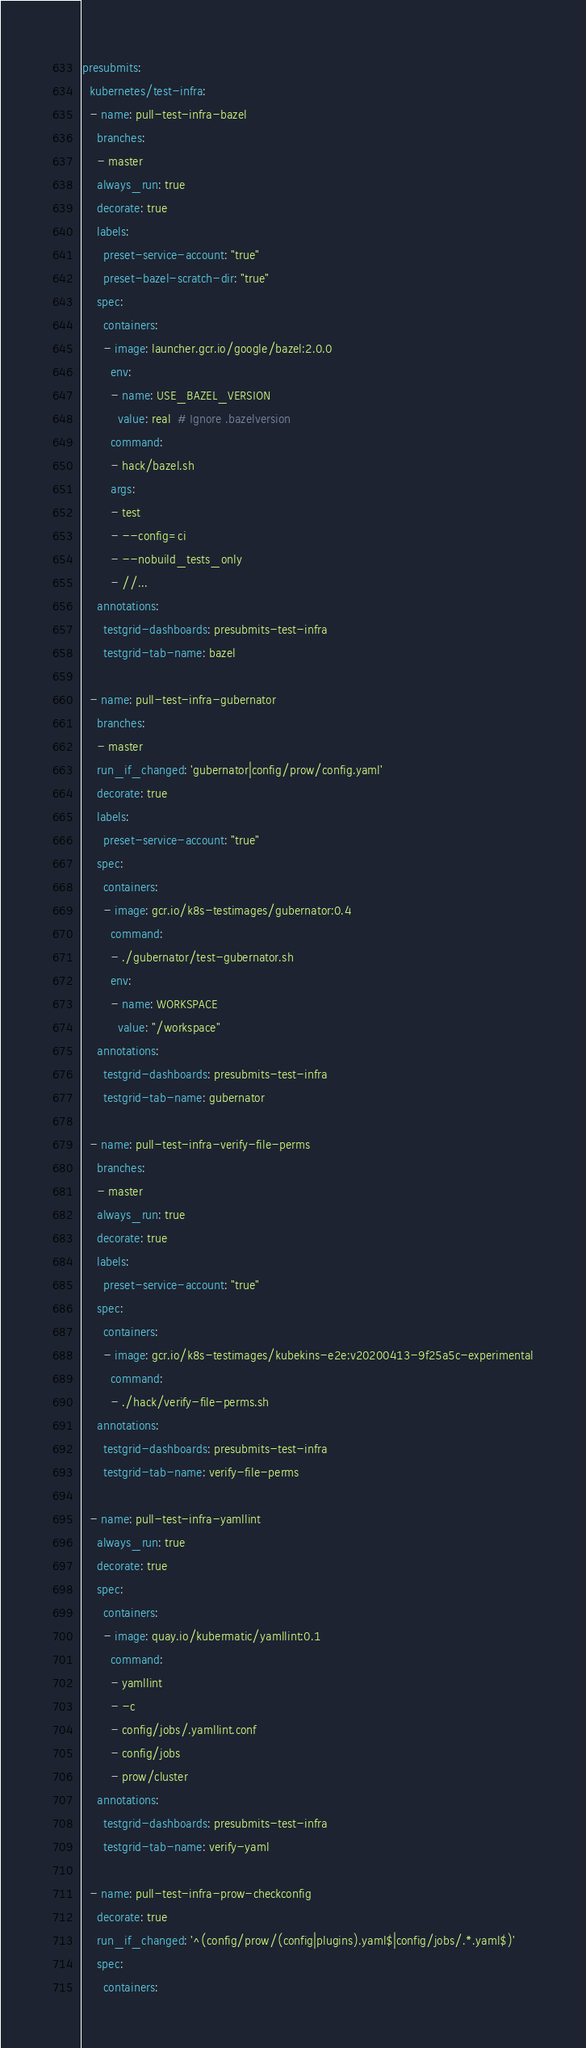Convert code to text. <code><loc_0><loc_0><loc_500><loc_500><_YAML_>presubmits:
  kubernetes/test-infra:
  - name: pull-test-infra-bazel
    branches:
    - master
    always_run: true
    decorate: true
    labels:
      preset-service-account: "true"
      preset-bazel-scratch-dir: "true"
    spec:
      containers:
      - image: launcher.gcr.io/google/bazel:2.0.0
        env:
        - name: USE_BAZEL_VERSION
          value: real  # Ignore .bazelversion
        command:
        - hack/bazel.sh
        args:
        - test
        - --config=ci
        - --nobuild_tests_only
        - //...
    annotations:
      testgrid-dashboards: presubmits-test-infra
      testgrid-tab-name: bazel

  - name: pull-test-infra-gubernator
    branches:
    - master
    run_if_changed: 'gubernator|config/prow/config.yaml'
    decorate: true
    labels:
      preset-service-account: "true"
    spec:
      containers:
      - image: gcr.io/k8s-testimages/gubernator:0.4
        command:
        - ./gubernator/test-gubernator.sh
        env:
        - name: WORKSPACE
          value: "/workspace"
    annotations:
      testgrid-dashboards: presubmits-test-infra
      testgrid-tab-name: gubernator

  - name: pull-test-infra-verify-file-perms
    branches:
    - master
    always_run: true
    decorate: true
    labels:
      preset-service-account: "true"
    spec:
      containers:
      - image: gcr.io/k8s-testimages/kubekins-e2e:v20200413-9f25a5c-experimental
        command:
        - ./hack/verify-file-perms.sh
    annotations:
      testgrid-dashboards: presubmits-test-infra
      testgrid-tab-name: verify-file-perms

  - name: pull-test-infra-yamllint
    always_run: true
    decorate: true
    spec:
      containers:
      - image: quay.io/kubermatic/yamllint:0.1
        command:
        - yamllint
        - -c
        - config/jobs/.yamllint.conf
        - config/jobs
        - prow/cluster
    annotations:
      testgrid-dashboards: presubmits-test-infra
      testgrid-tab-name: verify-yaml

  - name: pull-test-infra-prow-checkconfig
    decorate: true
    run_if_changed: '^(config/prow/(config|plugins).yaml$|config/jobs/.*.yaml$)'
    spec:
      containers:</code> 